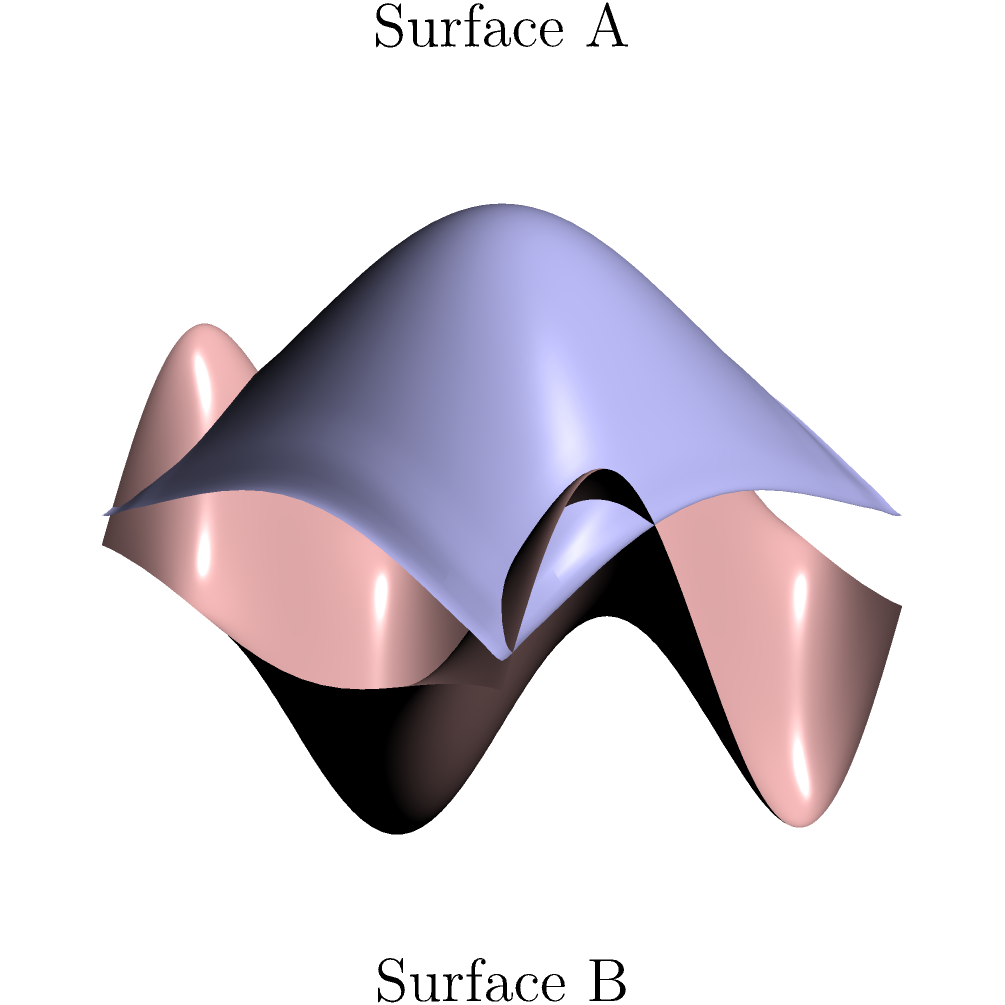Consider the two non-Euclidean surfaces shown in the diagram, representing different drug delivery platforms. Surface A is described by the equation $z = 0.5e^{-0.1(x^2+y^2)}$, while Surface B is described by $z = -0.3\sin(x)\cos(y)$. Which surface is likely to have a higher drug absorption rate, and why? To determine which surface is likely to have a higher drug absorption rate, we need to consider the curvature of each surface:

1. Surface A: $z = 0.5e^{-0.1(x^2+y^2)}$
   - This is a Gaussian surface with a single peak at the center.
   - The curvature is highest at the center and decreases radially outward.
   - The surface is smooth and continuous.

2. Surface B: $z = -0.3\sin(x)\cos(y)$
   - This is a periodic surface with multiple peaks and troughs.
   - The curvature varies periodically across the surface.
   - The surface has more undulations and a larger surface area.

3. Impact on drug absorption:
   - Surface area: Surface B has a larger surface area due to its periodic nature, which provides more contact points for drug absorption.
   - Curvature variability: Surface B has more regions of high curvature, which can create micro-environments that enhance drug retention and absorption.
   - Diffusion pathways: The undulating nature of Surface B creates more diverse diffusion pathways for drug molecules, potentially increasing absorption rates.

4. Conclusion:
   Surface B is likely to have a higher drug absorption rate due to its larger surface area, more varied curvature, and complex topography, which can enhance drug retention and create more opportunities for absorption.
Answer: Surface B, due to larger surface area and varied curvature. 